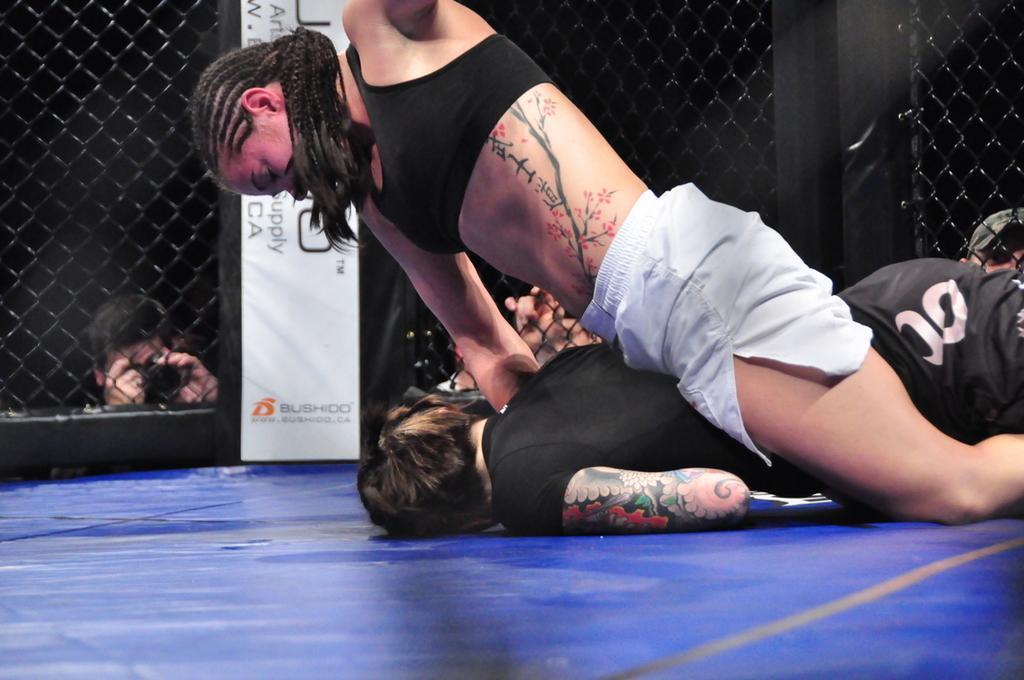How would you summarize this image in a sentence or two? In this picture there is a woman sitting on a person on a blue surface and there is a fence beside them and there are few other persons outside the fence. 